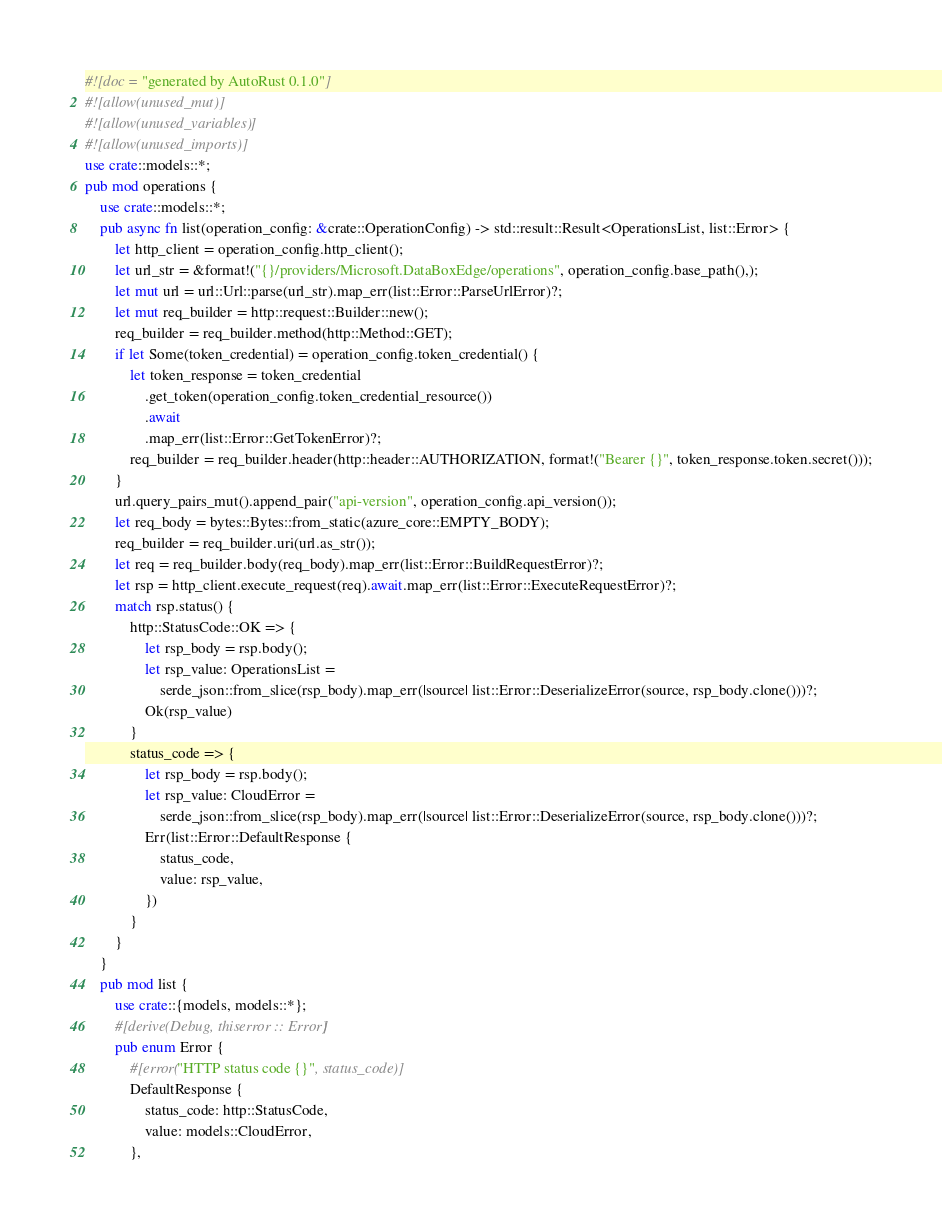<code> <loc_0><loc_0><loc_500><loc_500><_Rust_>#![doc = "generated by AutoRust 0.1.0"]
#![allow(unused_mut)]
#![allow(unused_variables)]
#![allow(unused_imports)]
use crate::models::*;
pub mod operations {
    use crate::models::*;
    pub async fn list(operation_config: &crate::OperationConfig) -> std::result::Result<OperationsList, list::Error> {
        let http_client = operation_config.http_client();
        let url_str = &format!("{}/providers/Microsoft.DataBoxEdge/operations", operation_config.base_path(),);
        let mut url = url::Url::parse(url_str).map_err(list::Error::ParseUrlError)?;
        let mut req_builder = http::request::Builder::new();
        req_builder = req_builder.method(http::Method::GET);
        if let Some(token_credential) = operation_config.token_credential() {
            let token_response = token_credential
                .get_token(operation_config.token_credential_resource())
                .await
                .map_err(list::Error::GetTokenError)?;
            req_builder = req_builder.header(http::header::AUTHORIZATION, format!("Bearer {}", token_response.token.secret()));
        }
        url.query_pairs_mut().append_pair("api-version", operation_config.api_version());
        let req_body = bytes::Bytes::from_static(azure_core::EMPTY_BODY);
        req_builder = req_builder.uri(url.as_str());
        let req = req_builder.body(req_body).map_err(list::Error::BuildRequestError)?;
        let rsp = http_client.execute_request(req).await.map_err(list::Error::ExecuteRequestError)?;
        match rsp.status() {
            http::StatusCode::OK => {
                let rsp_body = rsp.body();
                let rsp_value: OperationsList =
                    serde_json::from_slice(rsp_body).map_err(|source| list::Error::DeserializeError(source, rsp_body.clone()))?;
                Ok(rsp_value)
            }
            status_code => {
                let rsp_body = rsp.body();
                let rsp_value: CloudError =
                    serde_json::from_slice(rsp_body).map_err(|source| list::Error::DeserializeError(source, rsp_body.clone()))?;
                Err(list::Error::DefaultResponse {
                    status_code,
                    value: rsp_value,
                })
            }
        }
    }
    pub mod list {
        use crate::{models, models::*};
        #[derive(Debug, thiserror :: Error)]
        pub enum Error {
            #[error("HTTP status code {}", status_code)]
            DefaultResponse {
                status_code: http::StatusCode,
                value: models::CloudError,
            },</code> 